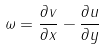<formula> <loc_0><loc_0><loc_500><loc_500>\omega = \frac { \partial v } { \partial x } - \frac { \partial u } { \partial y }</formula> 